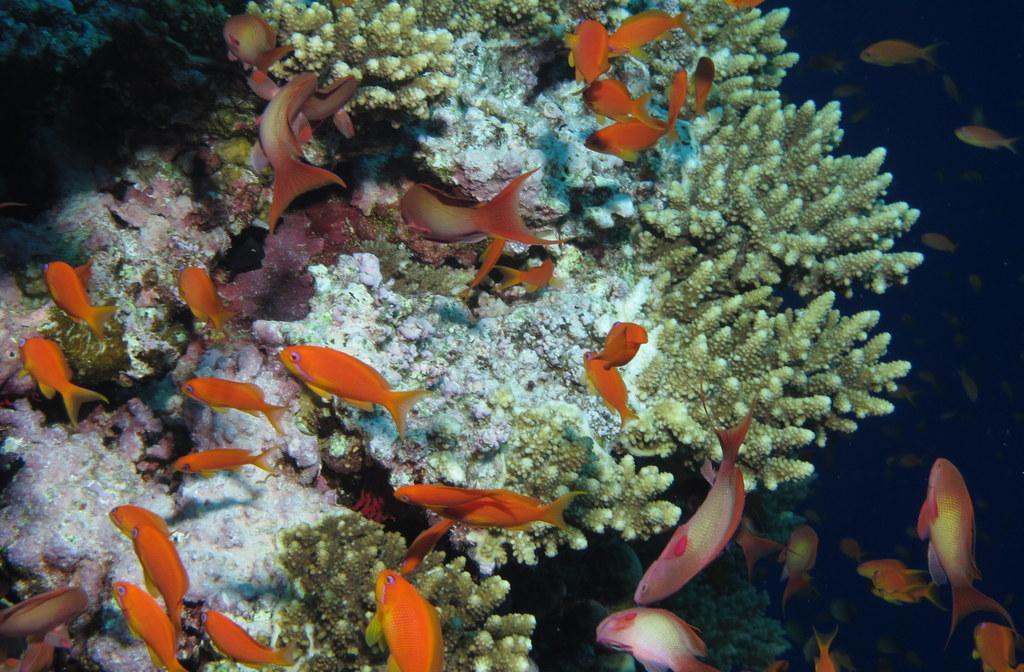Describe this image in one or two sentences. In the picture we can see deep in the water with a water plant and some fishes which are orange in color. 